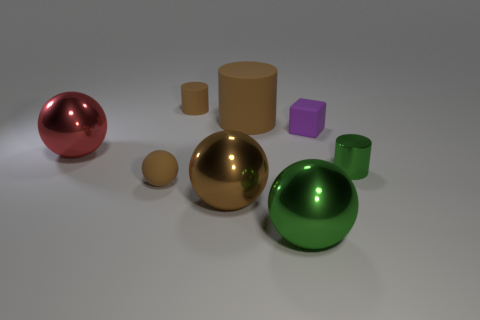There is a big cylinder that is the same color as the tiny matte ball; what is it made of?
Your answer should be compact. Rubber. What color is the small cylinder in front of the red metal thing?
Keep it short and to the point. Green. Does the matte object that is in front of the purple matte cube have the same size as the red ball?
Your answer should be compact. No. What is the size of the metallic object that is the same color as the metal cylinder?
Offer a terse response. Large. Is there a brown rubber cylinder of the same size as the matte ball?
Ensure brevity in your answer.  Yes. Does the shiny object that is behind the tiny green cylinder have the same color as the small rubber thing in front of the big red thing?
Your response must be concise. No. Are there any large metallic balls that have the same color as the tiny matte cylinder?
Keep it short and to the point. Yes. What number of other things are the same shape as the large green thing?
Offer a terse response. 3. What shape is the green metal thing left of the small cube?
Give a very brief answer. Sphere. Do the tiny shiny thing and the large object that is behind the red shiny thing have the same shape?
Offer a very short reply. Yes. 